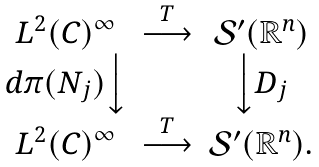Convert formula to latex. <formula><loc_0><loc_0><loc_500><loc_500>\begin{matrix} L ^ { 2 } ( C ) ^ { \infty } & \stackrel { T } \longrightarrow & \mathcal { S } ^ { \prime } ( \mathbb { R } ^ { n } ) \\ d \pi ( N _ { j } ) \Big \downarrow & & \Big \downarrow D _ { j } \\ L ^ { 2 } ( C ) ^ { \infty } & \stackrel { T } \longrightarrow & \mathcal { S } ^ { \prime } ( \mathbb { R } ^ { n } ) . \end{matrix}</formula> 